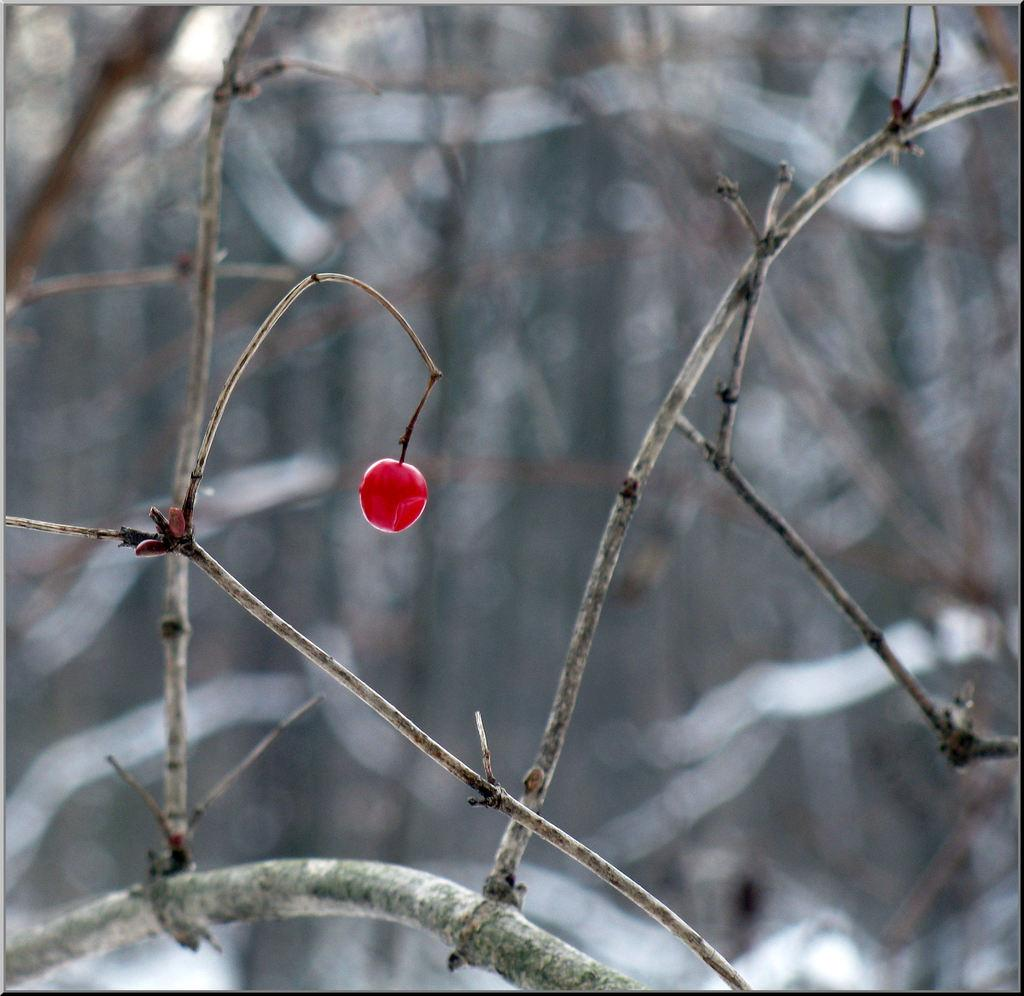What type of fruit is visible in the image? There is a cherry fruit in the image. Where is the cherry fruit located on the plant? The cherry fruit is on the branch of a plant. How many trains can be seen pushing the cherry fruit in the image? There are no trains present in the image, and the cherry fruit is not being pushed by any means. 